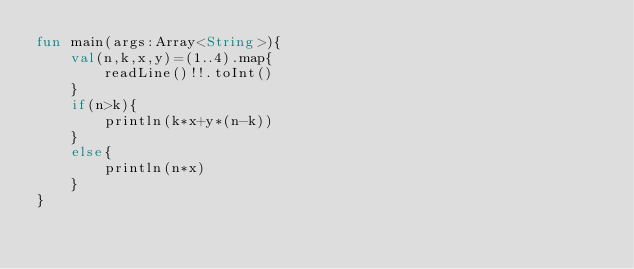<code> <loc_0><loc_0><loc_500><loc_500><_Kotlin_>fun main(args:Array<String>){
    val(n,k,x,y)=(1..4).map{
        readLine()!!.toInt()
    }
    if(n>k){
        println(k*x+y*(n-k))
    }
    else{
        println(n*x)
    }
}
</code> 